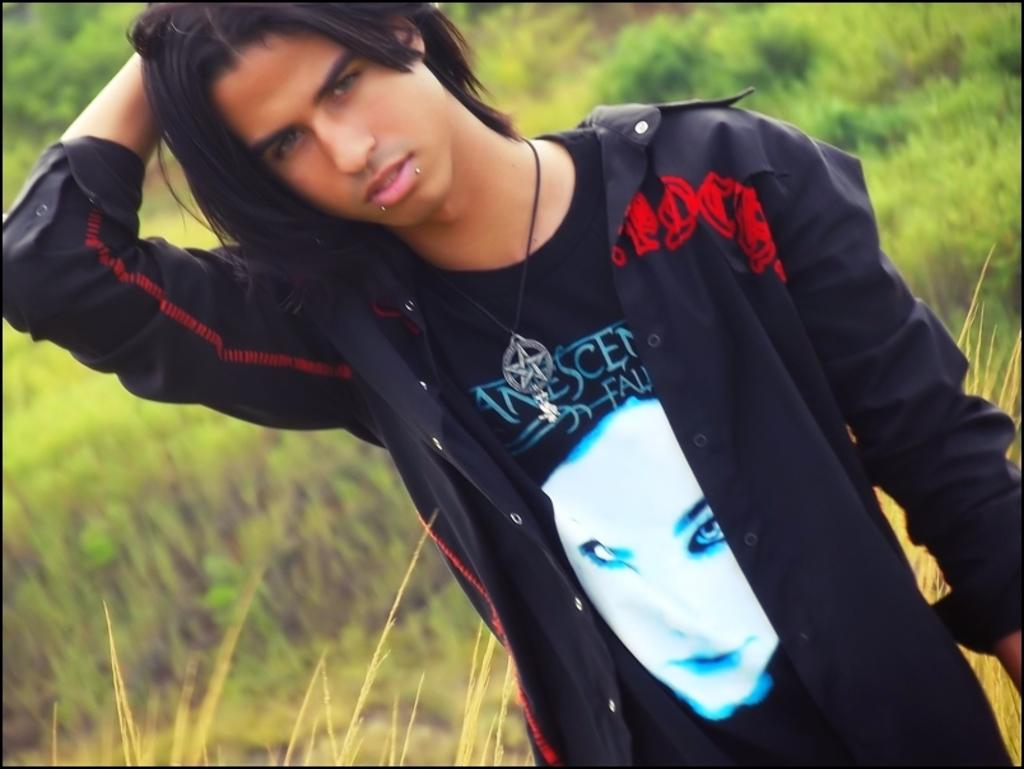What is the main subject of the picture? The main subject of the picture is a boy. What is the boy wearing? The boy is wearing a black T-shirt and a black jacket. What is the boy's posture in the picture? The boy is standing. What can be seen in the background of the picture? There are plants and trees in the background. How is the background depicted in the picture? The background is blurred. What type of machine is the boy operating in the picture? There is no machine present in the picture; the boy is simply standing and wearing a black T-shirt and jacket. 